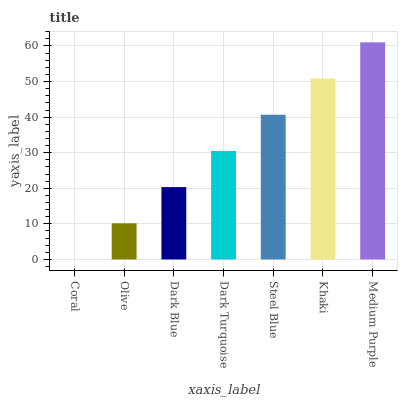Is Coral the minimum?
Answer yes or no. Yes. Is Medium Purple the maximum?
Answer yes or no. Yes. Is Olive the minimum?
Answer yes or no. No. Is Olive the maximum?
Answer yes or no. No. Is Olive greater than Coral?
Answer yes or no. Yes. Is Coral less than Olive?
Answer yes or no. Yes. Is Coral greater than Olive?
Answer yes or no. No. Is Olive less than Coral?
Answer yes or no. No. Is Dark Turquoise the high median?
Answer yes or no. Yes. Is Dark Turquoise the low median?
Answer yes or no. Yes. Is Khaki the high median?
Answer yes or no. No. Is Dark Blue the low median?
Answer yes or no. No. 